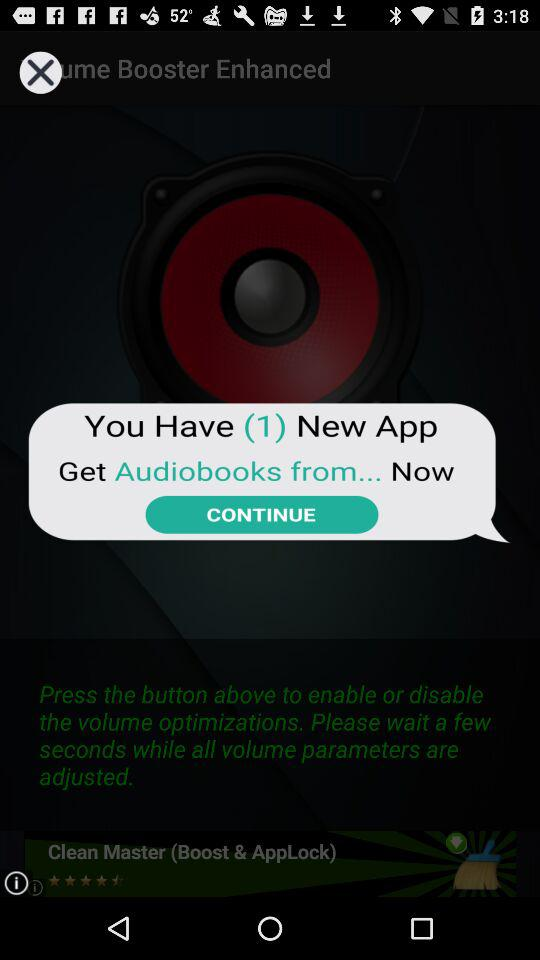What is the name of the new application? The name of the new application is "Audiobooks". 